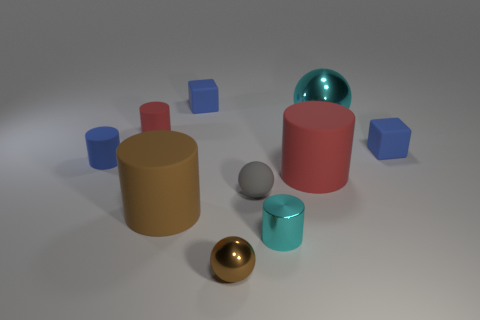Subtract all brown cylinders. How many cylinders are left? 4 Subtract all blue matte cylinders. How many cylinders are left? 4 Subtract all yellow cylinders. Subtract all green cubes. How many cylinders are left? 5 Subtract all cubes. How many objects are left? 8 Subtract 0 gray blocks. How many objects are left? 10 Subtract all blue matte cylinders. Subtract all shiny balls. How many objects are left? 7 Add 1 tiny shiny spheres. How many tiny shiny spheres are left? 2 Add 3 small blue cylinders. How many small blue cylinders exist? 4 